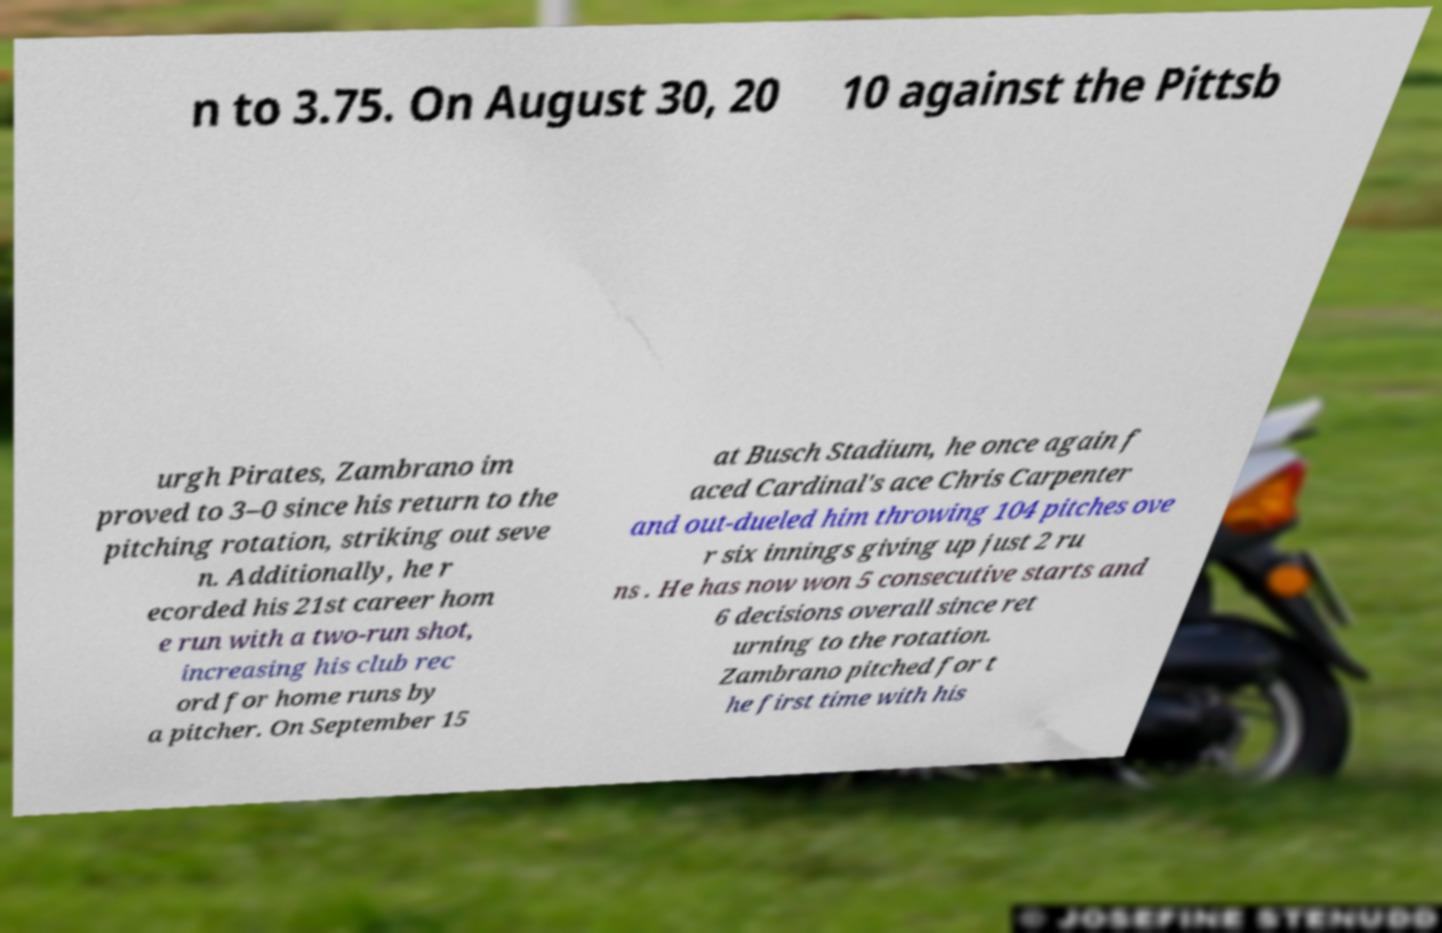What messages or text are displayed in this image? I need them in a readable, typed format. n to 3.75. On August 30, 20 10 against the Pittsb urgh Pirates, Zambrano im proved to 3–0 since his return to the pitching rotation, striking out seve n. Additionally, he r ecorded his 21st career hom e run with a two-run shot, increasing his club rec ord for home runs by a pitcher. On September 15 at Busch Stadium, he once again f aced Cardinal's ace Chris Carpenter and out-dueled him throwing 104 pitches ove r six innings giving up just 2 ru ns . He has now won 5 consecutive starts and 6 decisions overall since ret urning to the rotation. Zambrano pitched for t he first time with his 